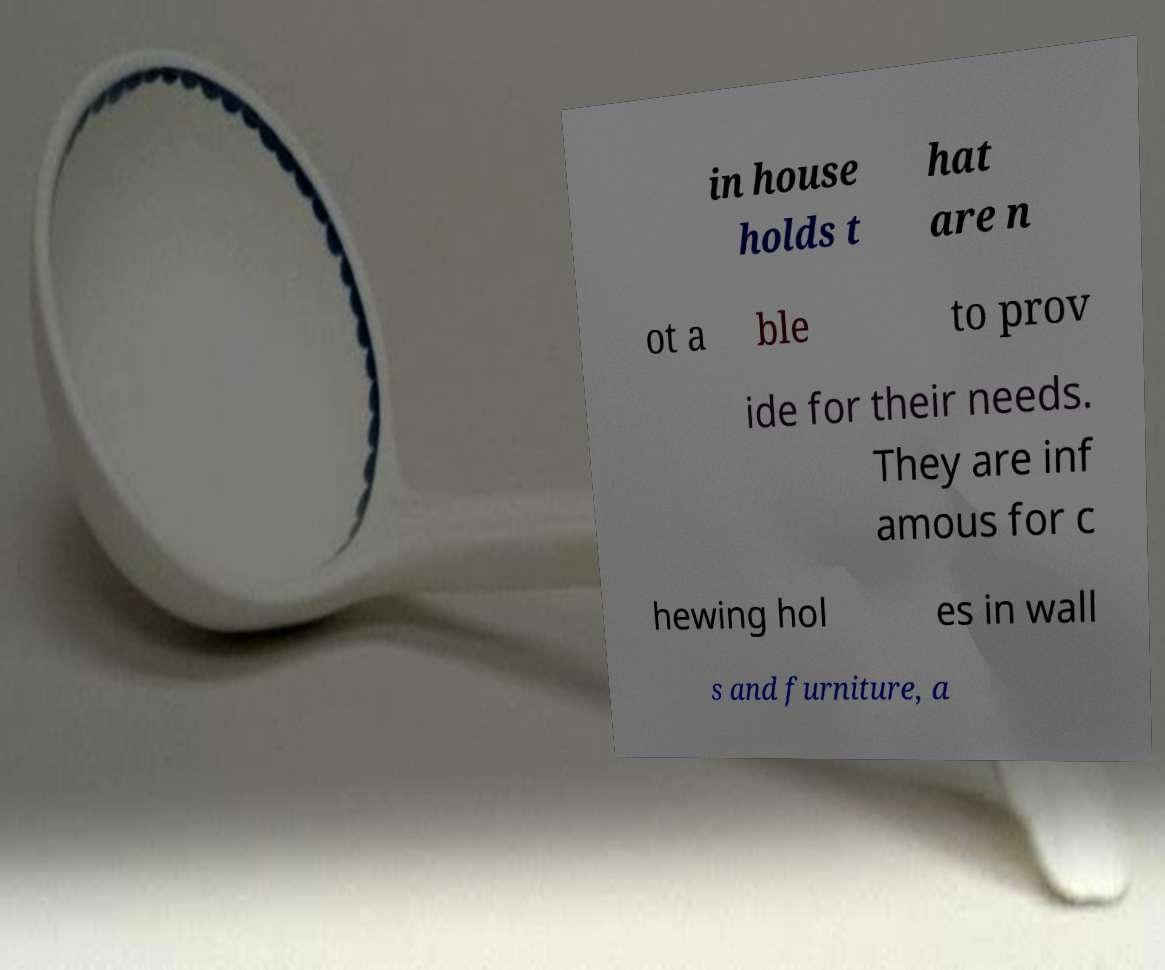There's text embedded in this image that I need extracted. Can you transcribe it verbatim? in house holds t hat are n ot a ble to prov ide for their needs. They are inf amous for c hewing hol es in wall s and furniture, a 